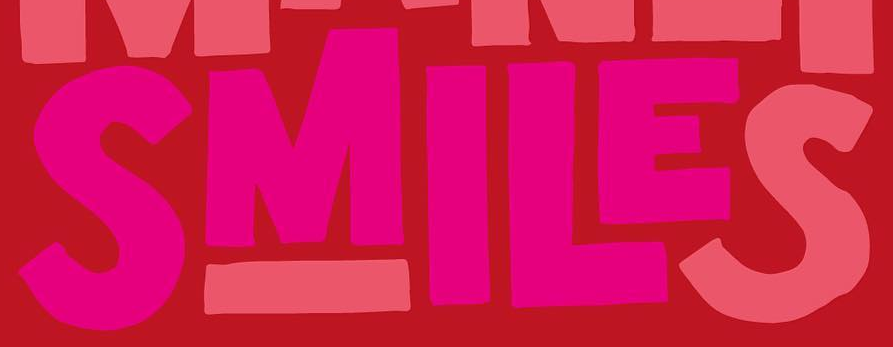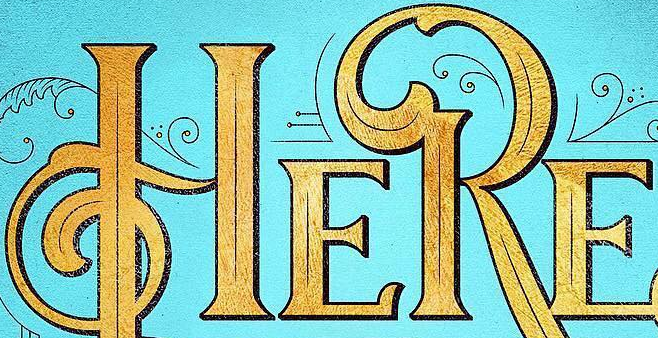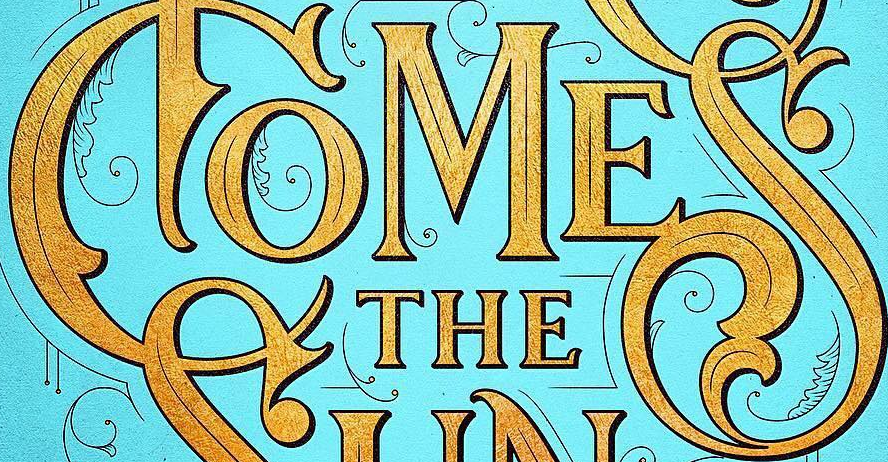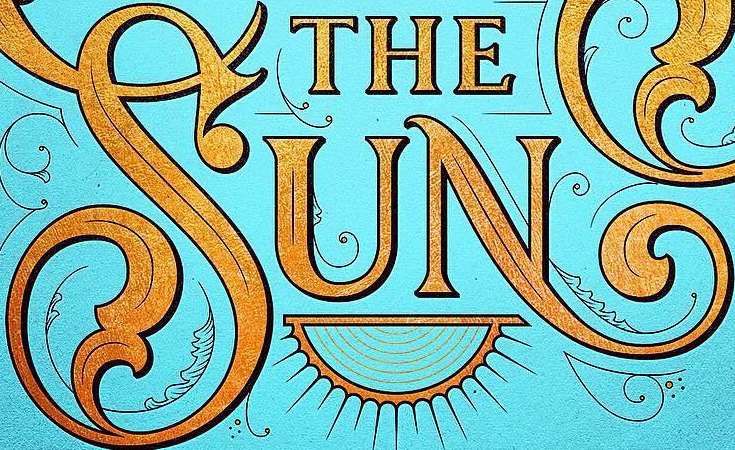What text appears in these images from left to right, separated by a semicolon? SMILES; HERE; COMES; SUN 